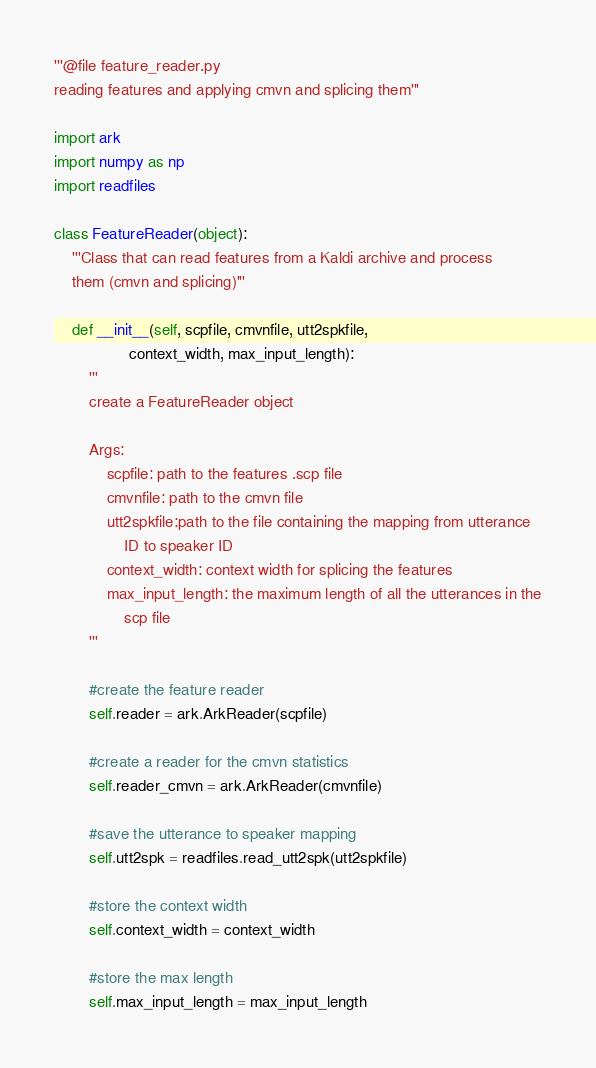Convert code to text. <code><loc_0><loc_0><loc_500><loc_500><_Python_>'''@file feature_reader.py
reading features and applying cmvn and splicing them'''

import ark
import numpy as np
import readfiles

class FeatureReader(object):
    '''Class that can read features from a Kaldi archive and process
    them (cmvn and splicing)'''

    def __init__(self, scpfile, cmvnfile, utt2spkfile,
                 context_width, max_input_length):
        '''
        create a FeatureReader object

        Args:
            scpfile: path to the features .scp file
            cmvnfile: path to the cmvn file
            utt2spkfile:path to the file containing the mapping from utterance
                ID to speaker ID
            context_width: context width for splicing the features
            max_input_length: the maximum length of all the utterances in the
                scp file
        '''

        #create the feature reader
        self.reader = ark.ArkReader(scpfile)

        #create a reader for the cmvn statistics
        self.reader_cmvn = ark.ArkReader(cmvnfile)

        #save the utterance to speaker mapping
        self.utt2spk = readfiles.read_utt2spk(utt2spkfile)

        #store the context width
        self.context_width = context_width

        #store the max length
        self.max_input_length = max_input_length
</code> 